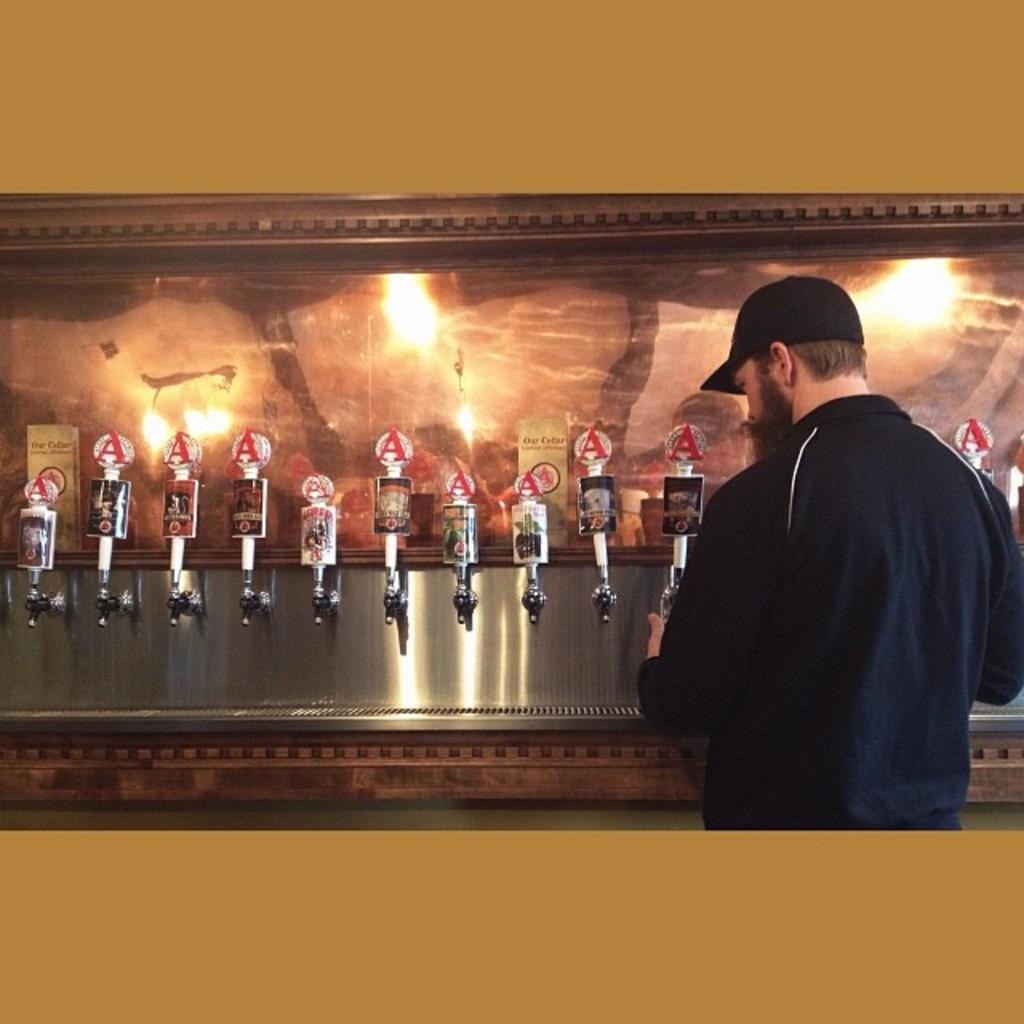In one or two sentences, can you explain what this image depicts? At the bottom of this image, there is a brown color surface. Behind this brown color surface, there is a person in a violet color jacket holding a bottle and filling it. In the background, there are tapes and a wall. 